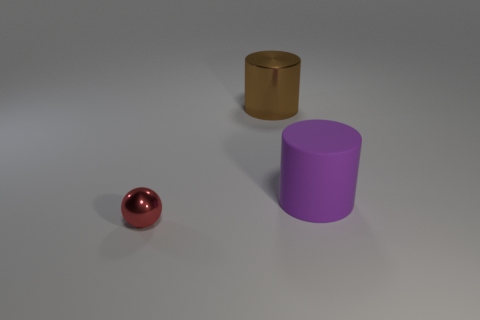Are there any other things that have the same size as the red object?
Your answer should be compact. No. The object on the left side of the big object that is left of the big object that is in front of the large brown shiny cylinder is made of what material?
Provide a short and direct response. Metal. How many other things are the same color as the sphere?
Your answer should be very brief. 0. How many red objects are small things or cylinders?
Your answer should be compact. 1. What is the large thing on the left side of the purple rubber thing made of?
Ensure brevity in your answer.  Metal. Are the large cylinder that is behind the big purple matte cylinder and the red ball made of the same material?
Ensure brevity in your answer.  Yes. The red thing has what shape?
Provide a succinct answer. Sphere. What number of red shiny objects are right of the large cylinder in front of the large cylinder behind the big rubber cylinder?
Give a very brief answer. 0. How many other objects are the same material as the brown thing?
Make the answer very short. 1. There is a cylinder that is the same size as the brown object; what material is it?
Your answer should be compact. Rubber. 